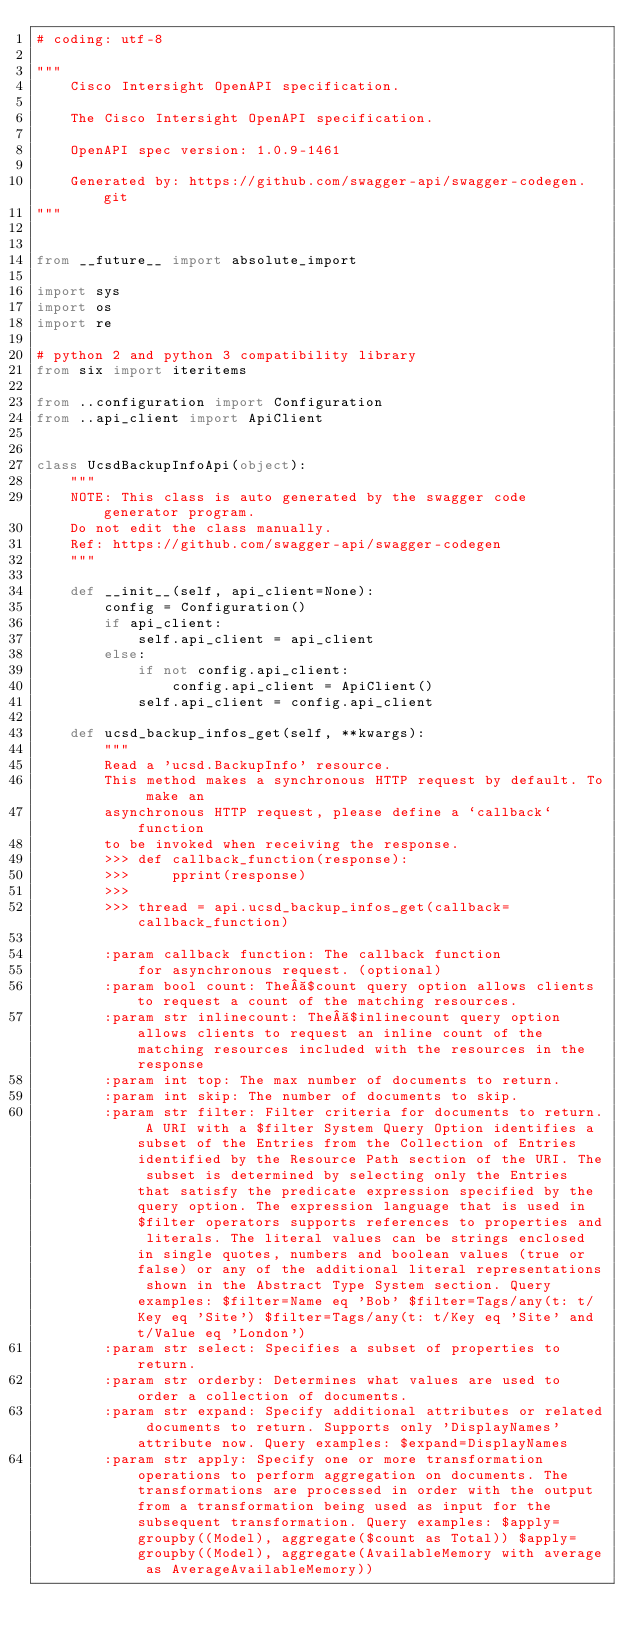<code> <loc_0><loc_0><loc_500><loc_500><_Python_># coding: utf-8

"""
    Cisco Intersight OpenAPI specification.

    The Cisco Intersight OpenAPI specification.

    OpenAPI spec version: 1.0.9-1461
    
    Generated by: https://github.com/swagger-api/swagger-codegen.git
"""


from __future__ import absolute_import

import sys
import os
import re

# python 2 and python 3 compatibility library
from six import iteritems

from ..configuration import Configuration
from ..api_client import ApiClient


class UcsdBackupInfoApi(object):
    """
    NOTE: This class is auto generated by the swagger code generator program.
    Do not edit the class manually.
    Ref: https://github.com/swagger-api/swagger-codegen
    """

    def __init__(self, api_client=None):
        config = Configuration()
        if api_client:
            self.api_client = api_client
        else:
            if not config.api_client:
                config.api_client = ApiClient()
            self.api_client = config.api_client

    def ucsd_backup_infos_get(self, **kwargs):
        """
        Read a 'ucsd.BackupInfo' resource.
        This method makes a synchronous HTTP request by default. To make an
        asynchronous HTTP request, please define a `callback` function
        to be invoked when receiving the response.
        >>> def callback_function(response):
        >>>     pprint(response)
        >>>
        >>> thread = api.ucsd_backup_infos_get(callback=callback_function)

        :param callback function: The callback function
            for asynchronous request. (optional)
        :param bool count: The $count query option allows clients to request a count of the matching resources.
        :param str inlinecount: The $inlinecount query option allows clients to request an inline count of the matching resources included with the resources in the response
        :param int top: The max number of documents to return.
        :param int skip: The number of documents to skip.
        :param str filter: Filter criteria for documents to return. A URI with a $filter System Query Option identifies a subset of the Entries from the Collection of Entries identified by the Resource Path section of the URI. The subset is determined by selecting only the Entries that satisfy the predicate expression specified by the query option. The expression language that is used in $filter operators supports references to properties and literals. The literal values can be strings enclosed in single quotes, numbers and boolean values (true or false) or any of the additional literal representations shown in the Abstract Type System section. Query examples: $filter=Name eq 'Bob' $filter=Tags/any(t: t/Key eq 'Site') $filter=Tags/any(t: t/Key eq 'Site' and t/Value eq 'London')
        :param str select: Specifies a subset of properties to return.
        :param str orderby: Determines what values are used to order a collection of documents.
        :param str expand: Specify additional attributes or related documents to return. Supports only 'DisplayNames' attribute now. Query examples: $expand=DisplayNames
        :param str apply: Specify one or more transformation operations to perform aggregation on documents. The transformations are processed in order with the output from a transformation being used as input for the subsequent transformation. Query examples: $apply=groupby((Model), aggregate($count as Total)) $apply=groupby((Model), aggregate(AvailableMemory with average as AverageAvailableMemory))</code> 